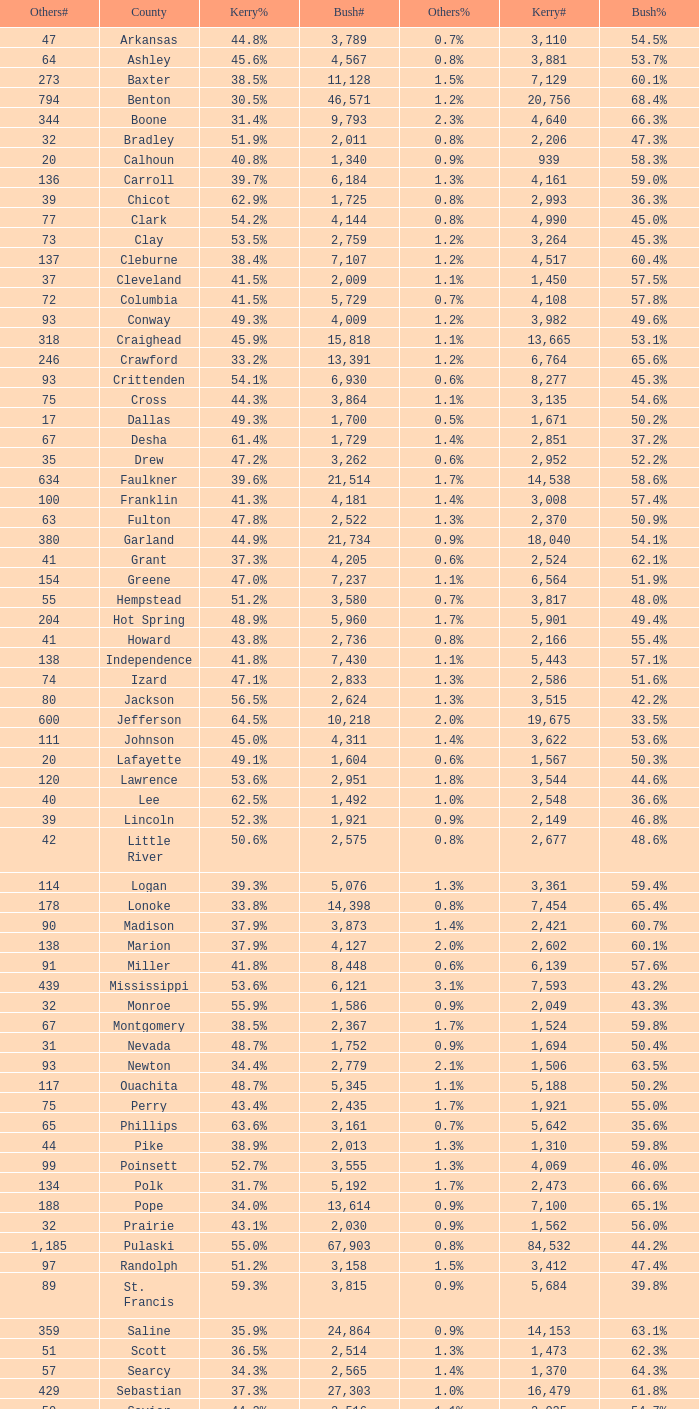What is the highest Bush#, when Others% is "1.7%", when Others# is less than 75, and when Kerry# is greater than 1,524? None. 